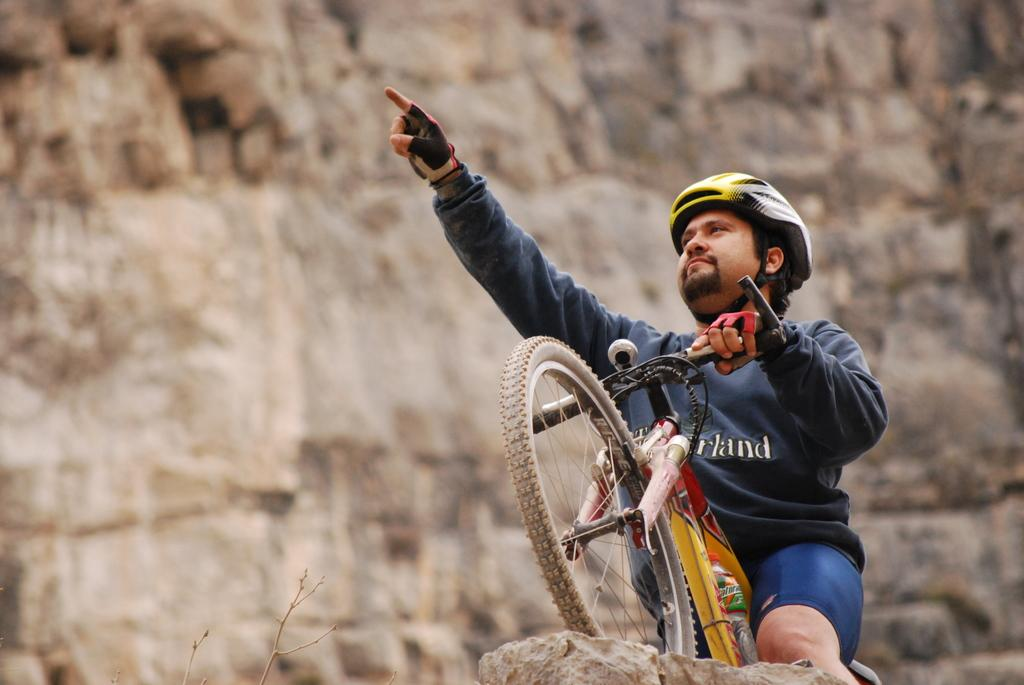What is the main subject of the image? There is a man in the image. What is the man wearing on his upper body? The man is wearing a t-shirt. What activity is the man engaged in? The man is riding a bicycle. What safety gear is the man wearing? The man is wearing a helmet on his head and gloves on both hands. Where is the man riding his bicycle? The man is standing on top of a rock. What type of zebra can be seen wearing a veil in the image? There is no zebra or veil present in the image; it features a man riding a bicycle. What type of table is visible in the image? There is no table present in the image. 